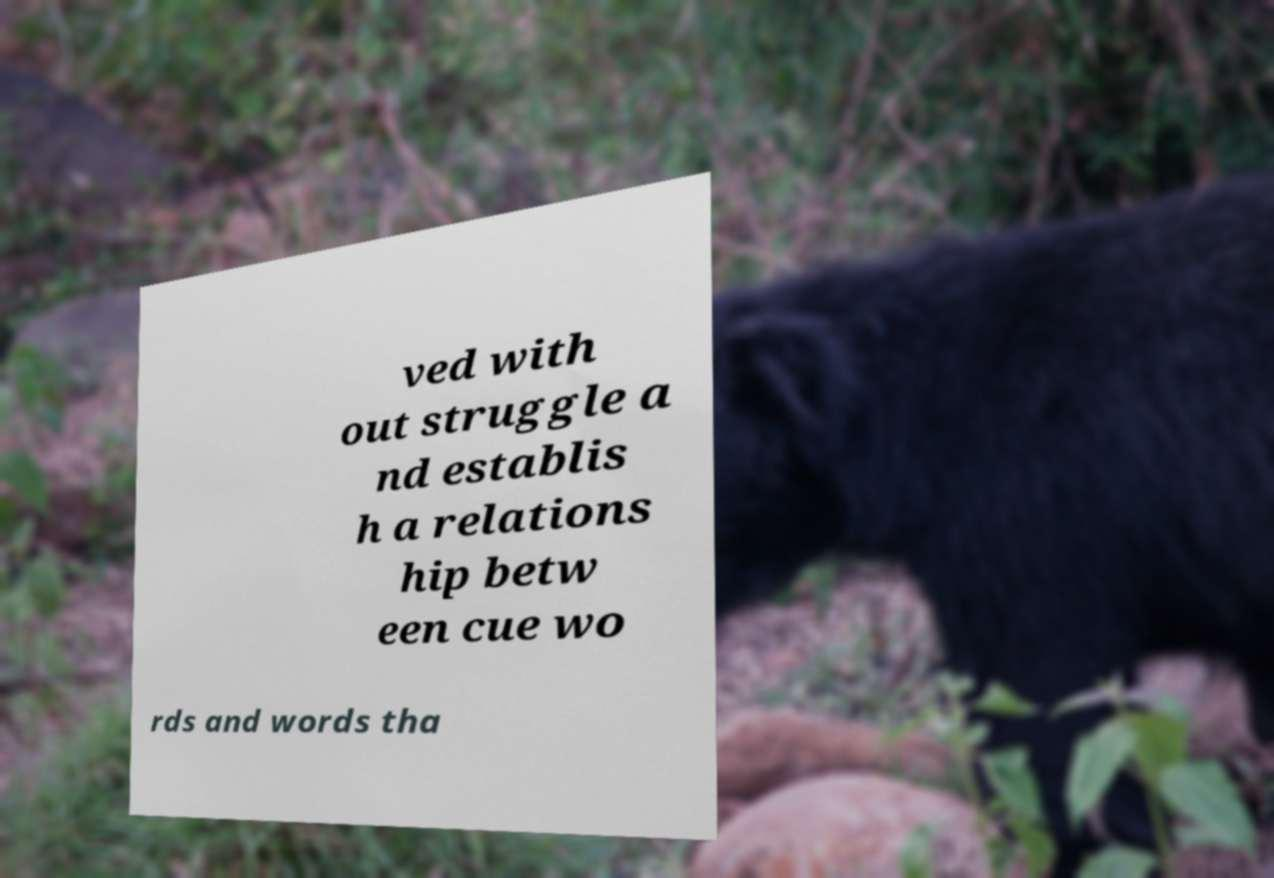Could you assist in decoding the text presented in this image and type it out clearly? ved with out struggle a nd establis h a relations hip betw een cue wo rds and words tha 